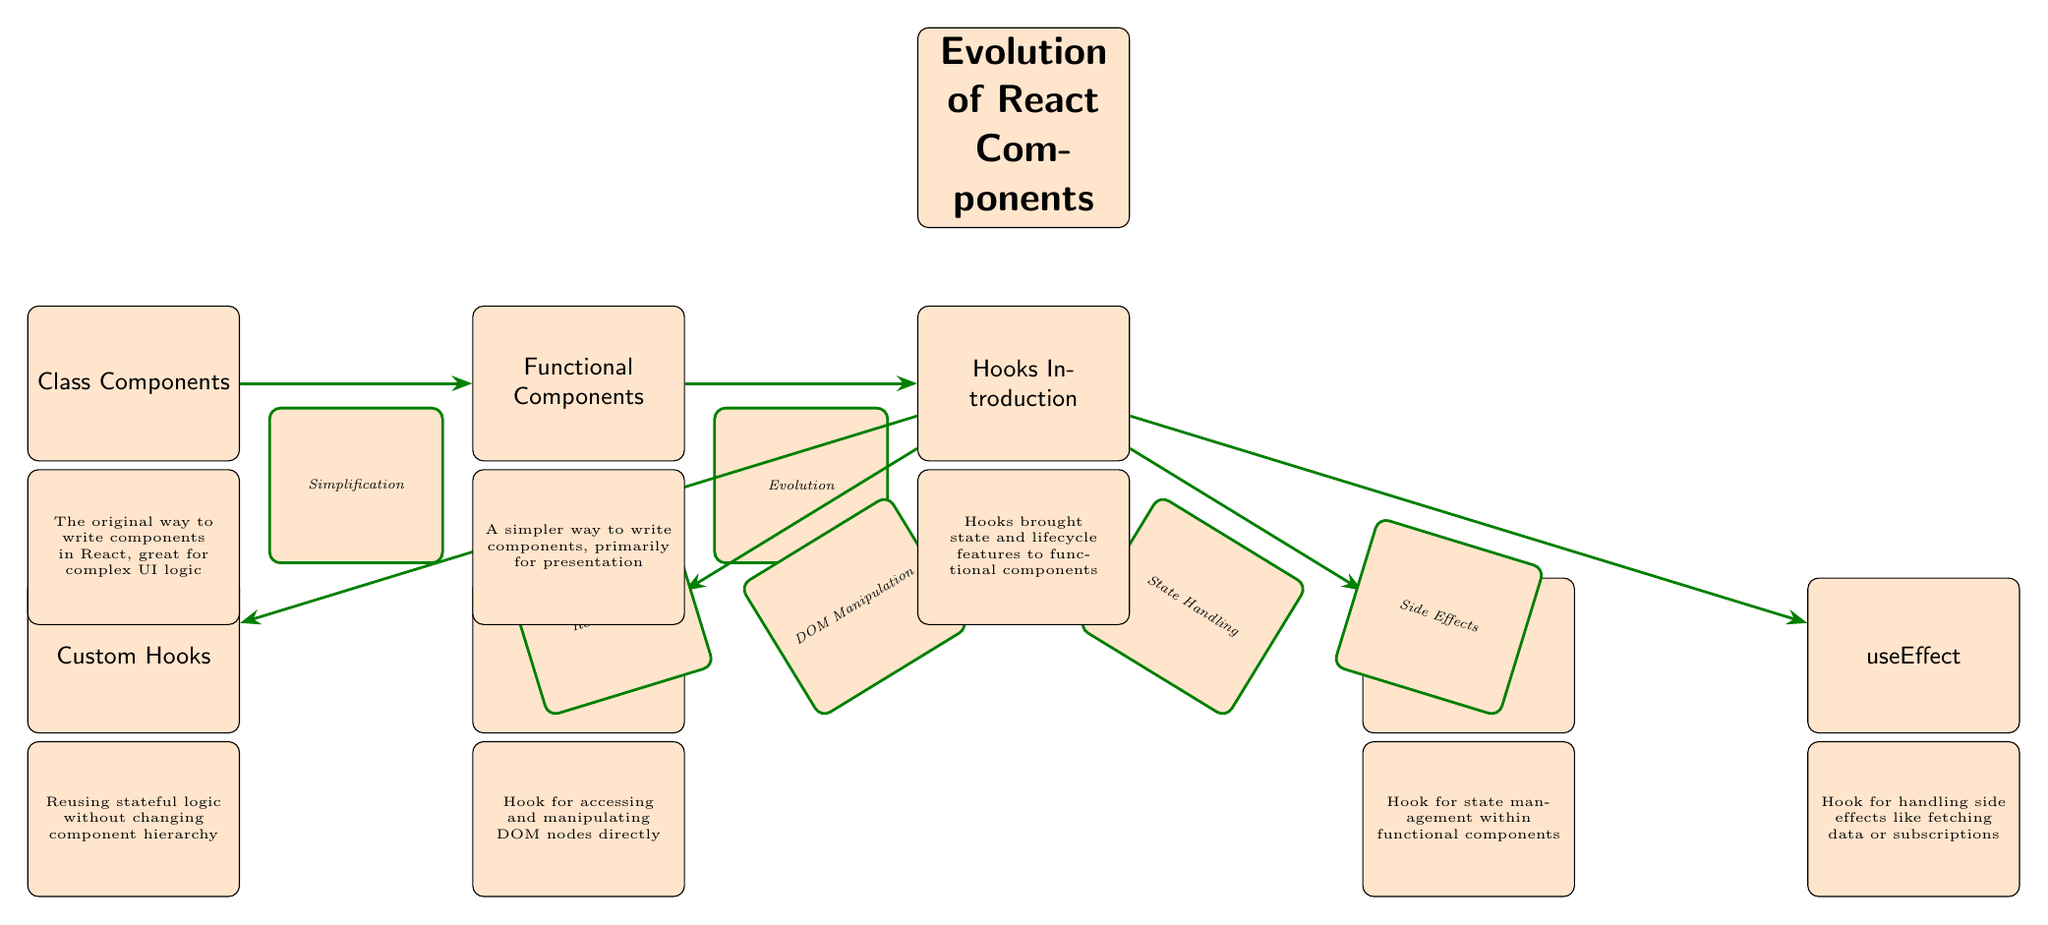What is the first type of React component mentioned in the diagram? The first node in the diagram on the left side is labeled "Class Components," which represents the original way to write components in React.
Answer: Class Components How many main component types are shown in the diagram? The diagram features three main component types: "Class Components," "Functional Components," and "Hooks Introduction." Therefore, there are three nodes that represent these types.
Answer: Three What does the arrow from "Functional Components" to "Hooks Introduction" signify? The arrow indicates a change in React component structure, specifically that "Functional Components" evolved into "Hooks Introduction," suggesting a significant advancement in handling component state and lifecycle features for functional components.
Answer: Evolution Which hook is specifically for managing state? The node labeled "useState" is directly connected to "Hooks Introduction," indicating that this hook is for state management within functional components.
Answer: useState How many hooks are connected to "Hooks Introduction"? The "Hooks Introduction" node has four outgoing arrows leading to "useState," "useEffect," "useRef," and "Custom Hooks," making a total of four hooks connected to it.
Answer: Four What does the relationship from "Custom Hooks" back to "Hooks Introduction" represent? The relationship is not directly shown, but you can deduce that "Custom Hooks" arises from "Hooks Introduction," highlighting its role in reusability of stateful logic. Therefore, it suggests that custom hooks are a product of advancements introduced in hooks.
Answer: Reusability What is the main purpose of "useEffect"? "useEffect" is connected to the "Hooks Introduction" node and is labeled to handle side effects, such as data fetching or subscriptions, thus its main purpose can be summarized as managing side effects in functional components.
Answer: Side Effects What type of components does "Functional Components" focus on? "Functional Components" primarily deal with presentation as indicated by its description below the node in the diagram, signifying that they focus on rendering UI without the complexities of managing state in class components.
Answer: Presentation 